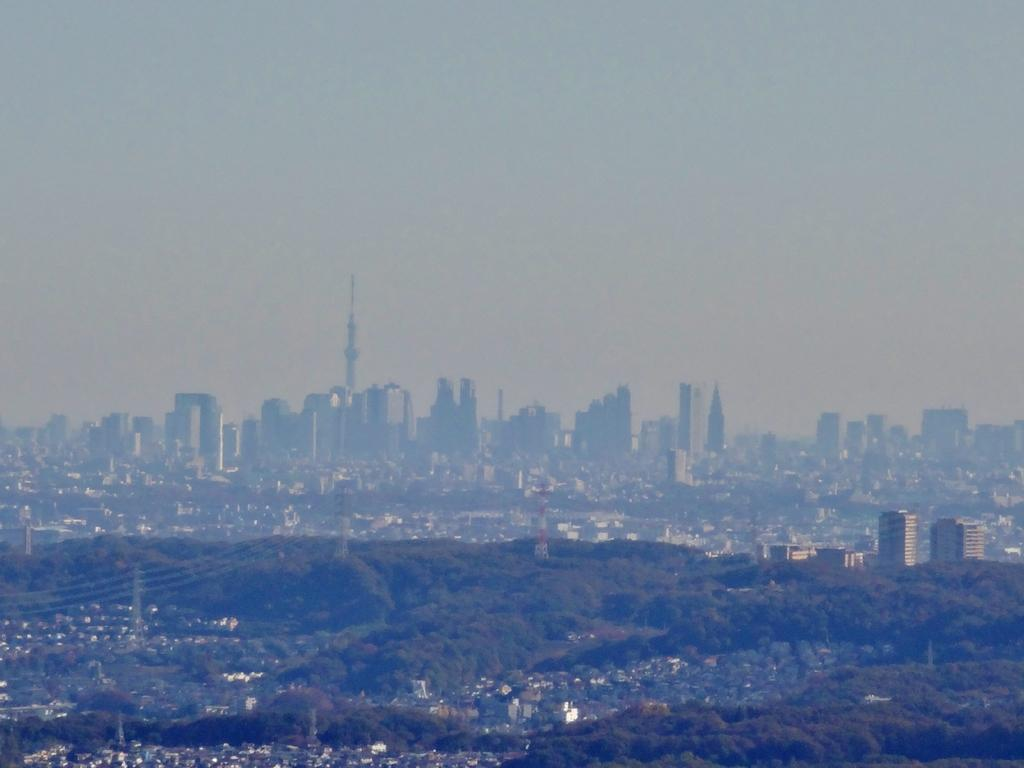What type of view is shown in the image? The image is an outside view. What can be seen at the bottom of the image? There are many trees and buildings visible at the bottom of the image. What is visible at the top of the image? The sky is visible at the top of the image. How many dogs are sitting on the canvas in the image? There is no canvas or dogs present in the image. 